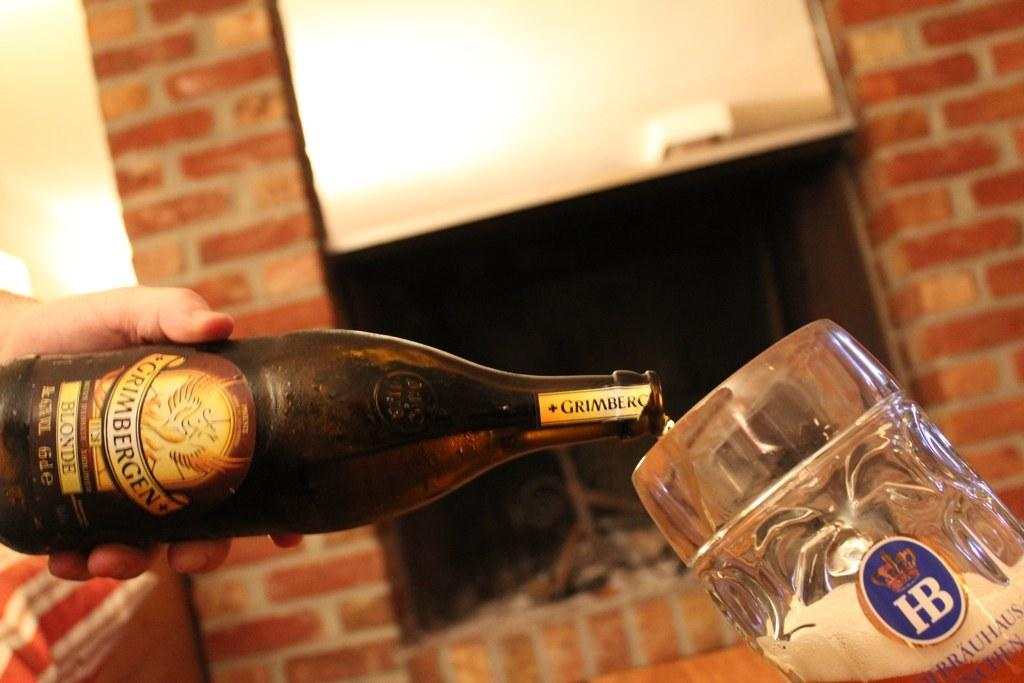Who is present in the image? There is a person in the image. What is the person doing in the image? The person is holding a beverage bottle and pouring the beverage into a glass tumbler. What can be seen in the background of the image? There are cobblestone walls in the background of the image. What type of pie is being served on the cobblestone walls in the image? There is no pie present in the image, and the cobblestone walls are in the background, not serving any food. 